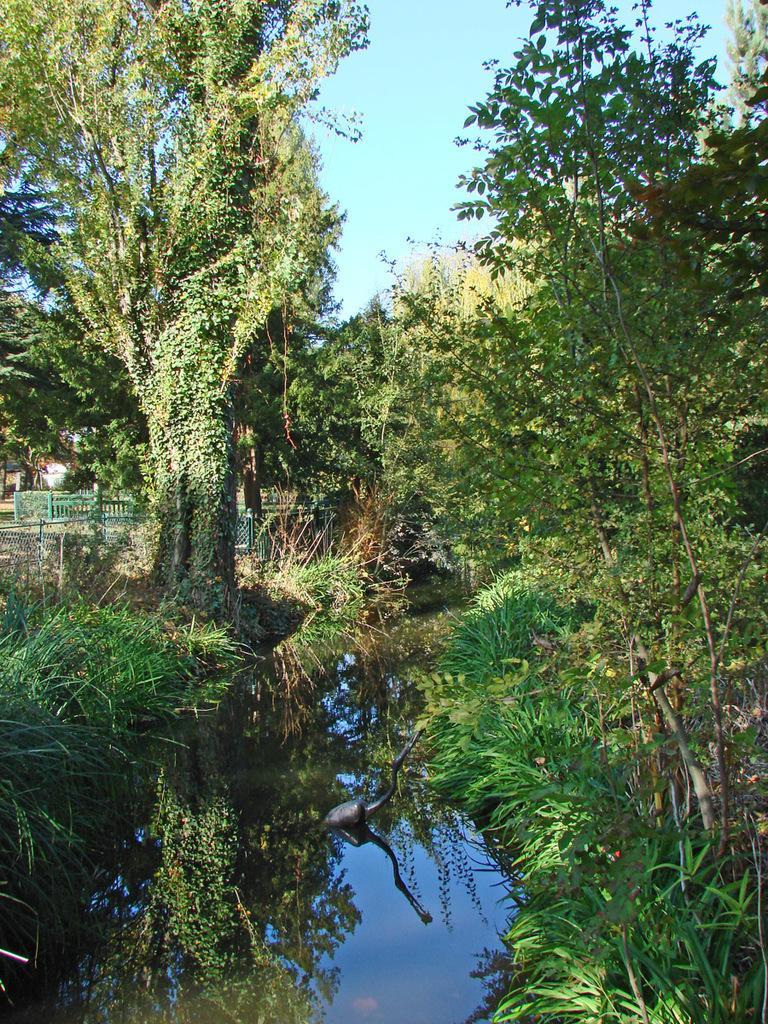Please provide a concise description of this image. In this image there is water at the bottom. In the background there are so many trees. At the top there is the sky. 